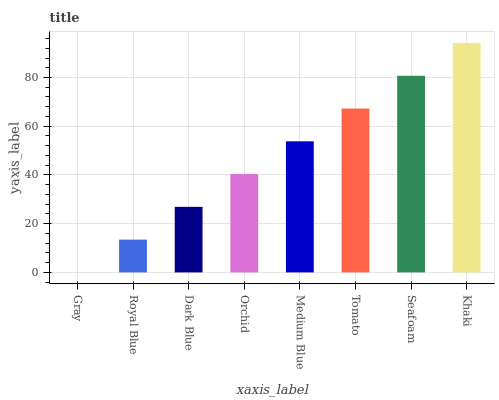Is Gray the minimum?
Answer yes or no. Yes. Is Khaki the maximum?
Answer yes or no. Yes. Is Royal Blue the minimum?
Answer yes or no. No. Is Royal Blue the maximum?
Answer yes or no. No. Is Royal Blue greater than Gray?
Answer yes or no. Yes. Is Gray less than Royal Blue?
Answer yes or no. Yes. Is Gray greater than Royal Blue?
Answer yes or no. No. Is Royal Blue less than Gray?
Answer yes or no. No. Is Medium Blue the high median?
Answer yes or no. Yes. Is Orchid the low median?
Answer yes or no. Yes. Is Khaki the high median?
Answer yes or no. No. Is Seafoam the low median?
Answer yes or no. No. 